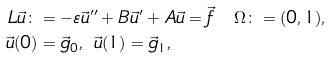Convert formula to latex. <formula><loc_0><loc_0><loc_500><loc_500>L \vec { u } \colon & = - \varepsilon \vec { u } ^ { \prime \prime } + B \vec { u } ^ { \prime } + A \vec { u } = \vec { f } \quad \Omega \colon = ( 0 , 1 ) , \\ \vec { u } ( 0 ) & = \vec { g } _ { 0 } , \ \vec { u } ( 1 ) = \vec { g } _ { 1 } ,</formula> 